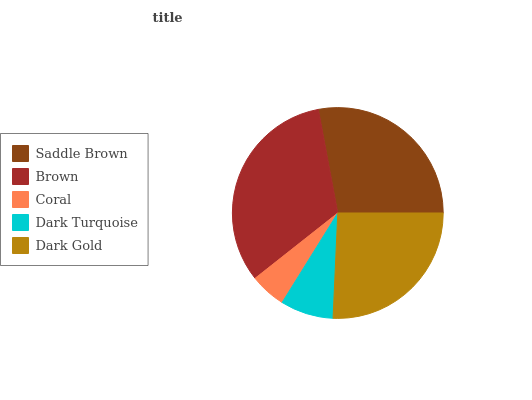Is Coral the minimum?
Answer yes or no. Yes. Is Brown the maximum?
Answer yes or no. Yes. Is Brown the minimum?
Answer yes or no. No. Is Coral the maximum?
Answer yes or no. No. Is Brown greater than Coral?
Answer yes or no. Yes. Is Coral less than Brown?
Answer yes or no. Yes. Is Coral greater than Brown?
Answer yes or no. No. Is Brown less than Coral?
Answer yes or no. No. Is Dark Gold the high median?
Answer yes or no. Yes. Is Dark Gold the low median?
Answer yes or no. Yes. Is Brown the high median?
Answer yes or no. No. Is Saddle Brown the low median?
Answer yes or no. No. 